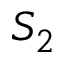<formula> <loc_0><loc_0><loc_500><loc_500>S _ { 2 }</formula> 